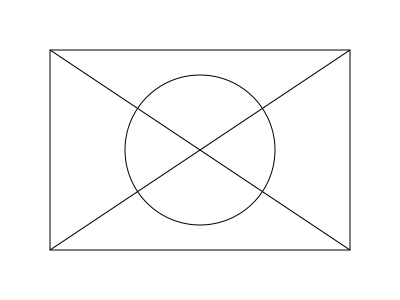In analyzing the composition of Pablo Picasso's "Les Demoiselles d'Avignon," you notice that the painting can be divided into geometric shapes. If the entire canvas is represented by a rectangle, and the central figure is enclosed in a circle, what is the ratio of the area of the circle to the area of the rectangle, assuming the circle's diameter is equal to the rectangle's height? To solve this problem, let's follow these steps:

1. Identify the given information:
   - The canvas is represented by a rectangle
   - The central figure is enclosed in a circle
   - The circle's diameter is equal to the rectangle's height

2. Let's denote the rectangle's width as $w$ and height as $h$

3. Calculate the area of the rectangle:
   $A_r = w \cdot h$

4. Calculate the diameter of the circle:
   The diameter is equal to the height of the rectangle, so $d = h$

5. Calculate the radius of the circle:
   $r = \frac{d}{2} = \frac{h}{2}$

6. Calculate the area of the circle:
   $A_c = \pi r^2 = \pi (\frac{h}{2})^2 = \frac{\pi h^2}{4}$

7. Calculate the ratio of the circle's area to the rectangle's area:
   $$\frac{A_c}{A_r} = \frac{\frac{\pi h^2}{4}}{w \cdot h} = \frac{\pi h}{4w}$$

8. Since we're told the circle's diameter is equal to the rectangle's height, we can substitute $h$ for $w$ in the ratio:
   $$\frac{A_c}{A_r} = \frac{\pi h}{4h} = \frac{\pi}{4} \approx 0.7854$$

Therefore, the ratio of the area of the circle to the area of the rectangle is $\frac{\pi}{4}$ or approximately 0.7854.
Answer: $\frac{\pi}{4}$ 